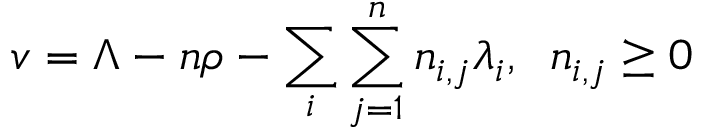Convert formula to latex. <formula><loc_0><loc_0><loc_500><loc_500>v = \Lambda - n \rho - \sum _ { i } \sum _ { j = 1 } ^ { n } n _ { i , j } \lambda _ { i } , \, n _ { i , j } \geq 0</formula> 